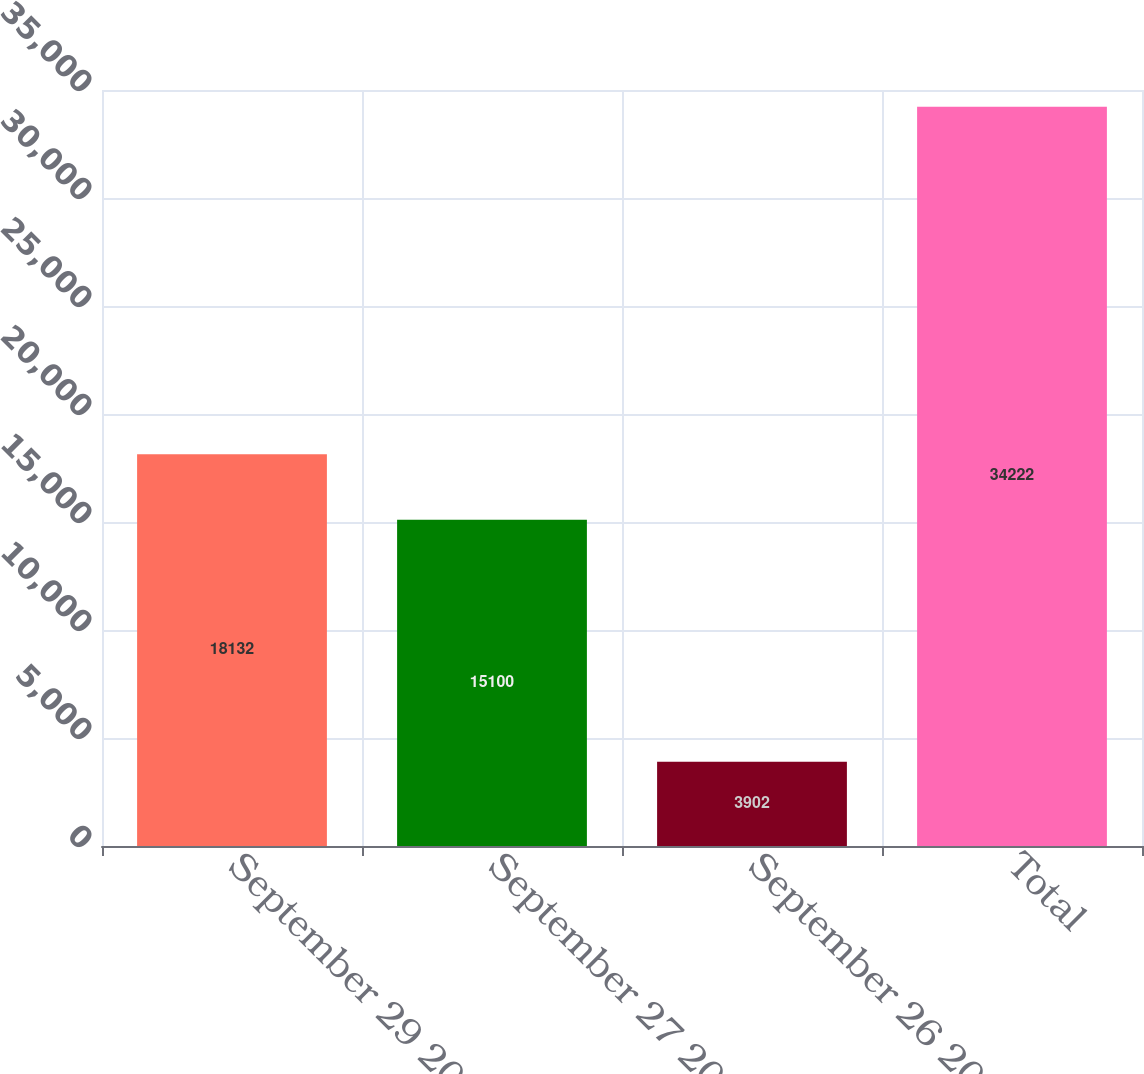<chart> <loc_0><loc_0><loc_500><loc_500><bar_chart><fcel>September 29 2007<fcel>September 27 2008<fcel>September 26 2009<fcel>Total<nl><fcel>18132<fcel>15100<fcel>3902<fcel>34222<nl></chart> 